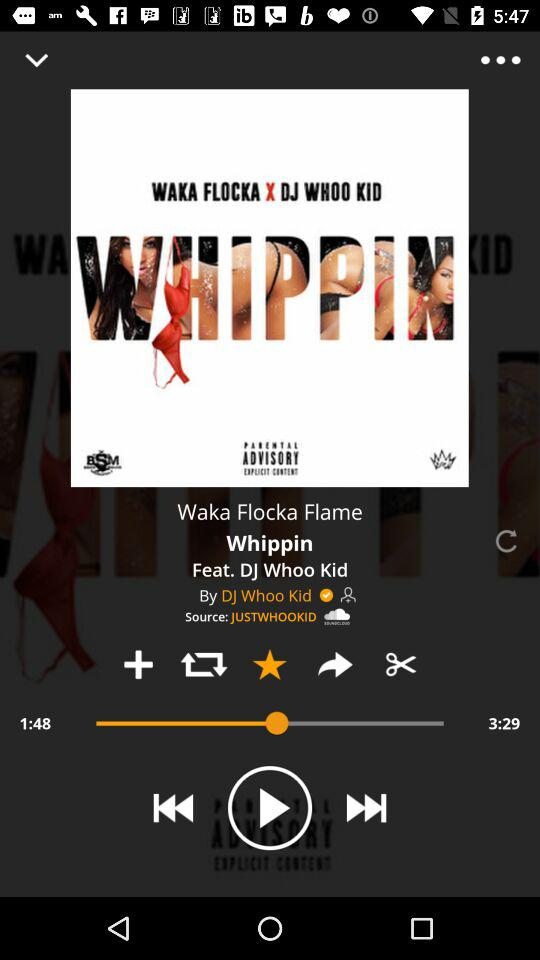What is the total duration of the song? The total duration of the song is 3 minutes 29 seconds. 